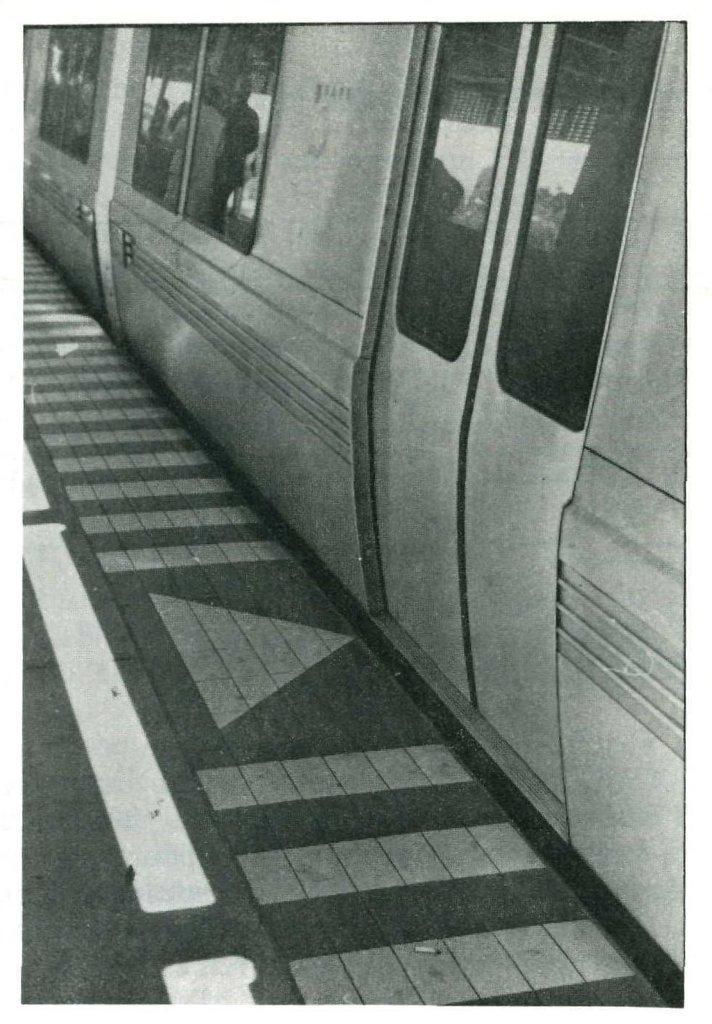What type of structure is visible in the image? There is a door in the image. What can be seen in addition to the door? There are windows in the image. What type of vehicle do the windows belong to? The windows belong to a train. What is the pathway used for in the image? The pathway is visible in the image, but its purpose is not specified. What type of trousers can be seen hanging on the door in the image? There are no trousers visible in the image; only a door, windows, and a pathway are present. 